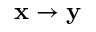Convert formula to latex. <formula><loc_0><loc_0><loc_500><loc_500>\mathbf x \to \mathbf y</formula> 